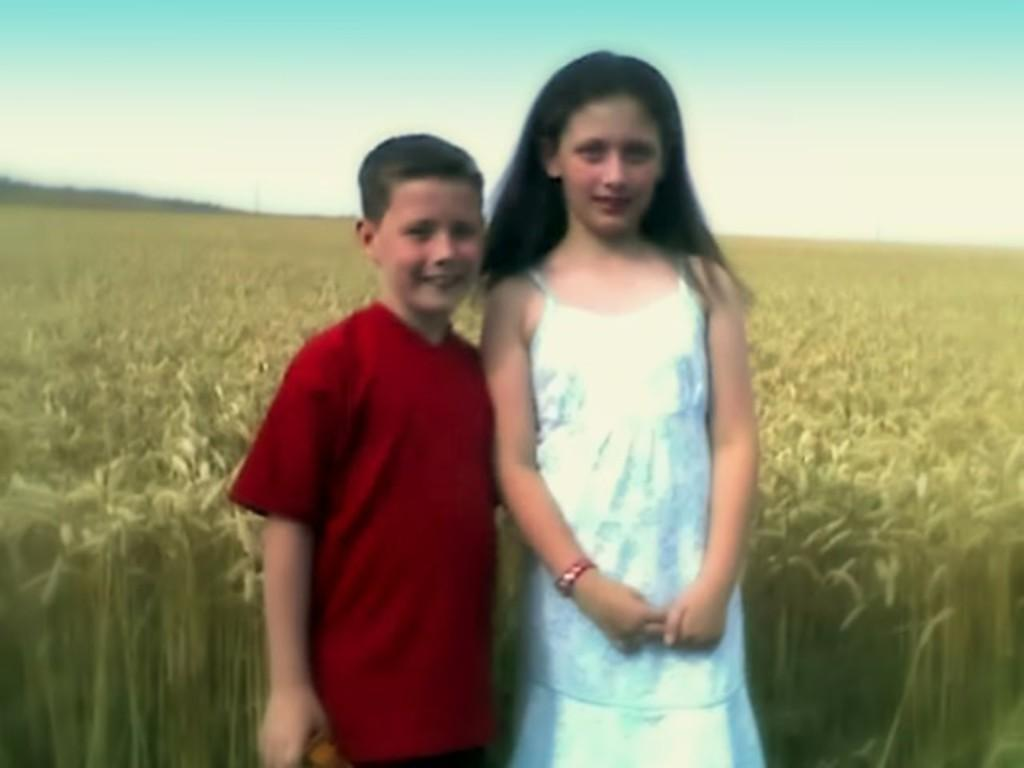How many kids are in the image? There are two kids in the center of the image. What are the kids doing in the image? The kids are standing and smiling. What can be seen in the background of the image? There is a sky, clouds, and plants visible in the background of the image. What rule do the giants follow on the island in the image? There are no giants or islands present in the image; it features two kids standing and smiling. 